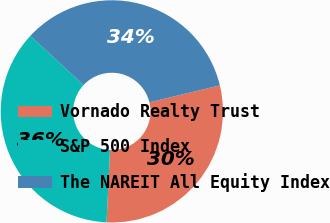Convert chart. <chart><loc_0><loc_0><loc_500><loc_500><pie_chart><fcel>Vornado Realty Trust<fcel>S&P 500 Index<fcel>The NAREIT All Equity Index<nl><fcel>29.52%<fcel>36.14%<fcel>34.34%<nl></chart> 